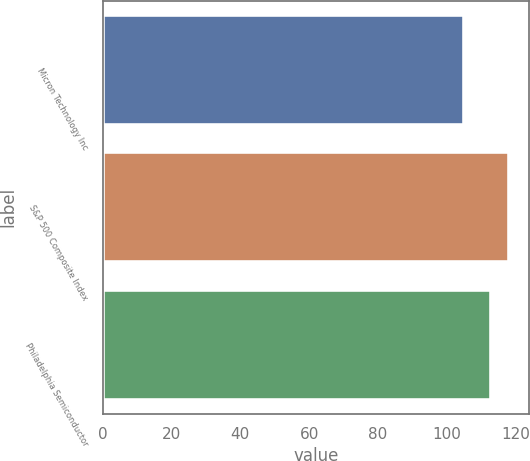Convert chart. <chart><loc_0><loc_0><loc_500><loc_500><bar_chart><fcel>Micron Technology Inc<fcel>S&P 500 Composite Index<fcel>Philadelphia Semiconductor<nl><fcel>105<fcel>118<fcel>113<nl></chart> 